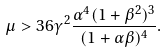Convert formula to latex. <formula><loc_0><loc_0><loc_500><loc_500>\mu > 3 6 \gamma ^ { 2 } \frac { \alpha ^ { 4 } ( 1 + \beta ^ { 2 } ) ^ { 3 } } { ( 1 + \alpha \beta ) ^ { 4 } } .</formula> 